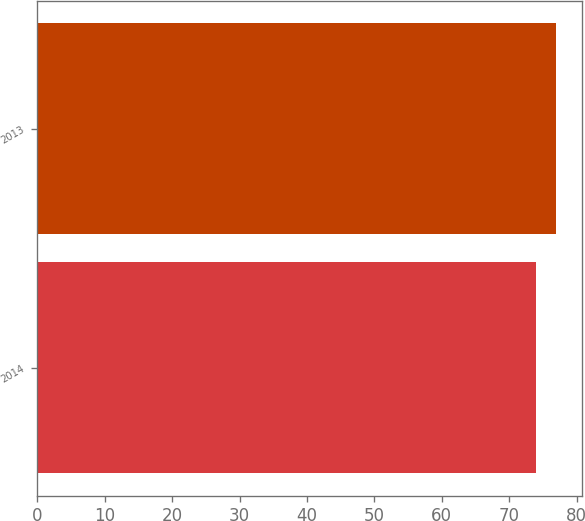Convert chart. <chart><loc_0><loc_0><loc_500><loc_500><bar_chart><fcel>2014<fcel>2013<nl><fcel>74<fcel>77<nl></chart> 